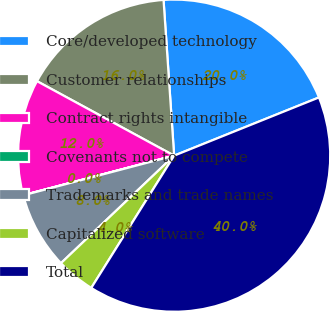<chart> <loc_0><loc_0><loc_500><loc_500><pie_chart><fcel>Core/developed technology<fcel>Customer relationships<fcel>Contract rights intangible<fcel>Covenants not to compete<fcel>Trademarks and trade names<fcel>Capitalized software<fcel>Total<nl><fcel>20.0%<fcel>16.0%<fcel>12.0%<fcel>0.01%<fcel>8.0%<fcel>4.0%<fcel>39.99%<nl></chart> 